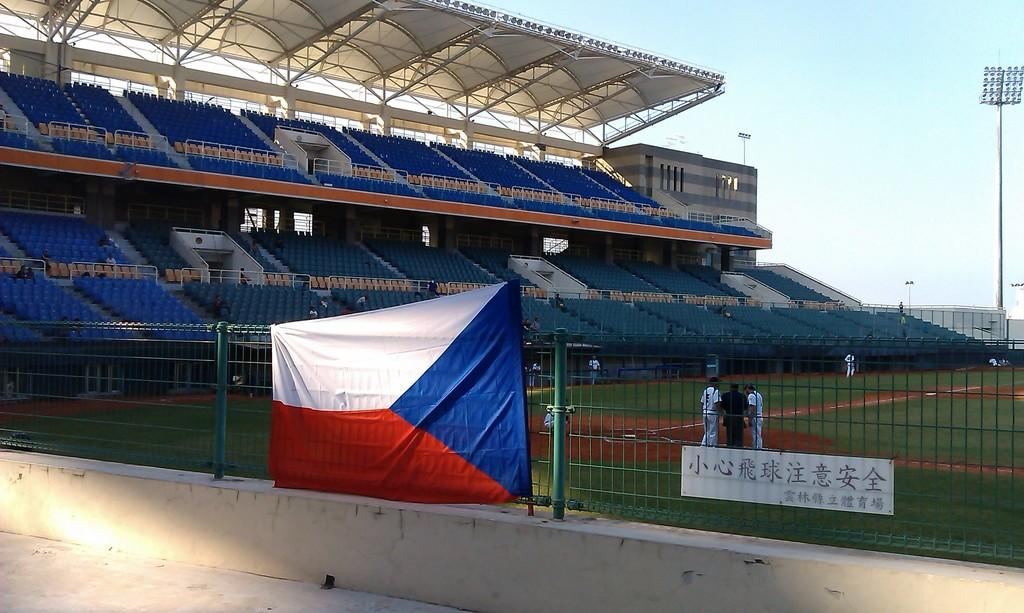<image>
Present a compact description of the photo's key features. A baseball team is practicing at an empty field with Chinese characters. 